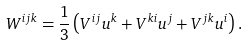Convert formula to latex. <formula><loc_0><loc_0><loc_500><loc_500>W ^ { i j k } = \frac { 1 } { 3 } \left ( V ^ { i j } u ^ { k } + V ^ { k i } u ^ { j } + V ^ { j k } u ^ { i } \right ) .</formula> 